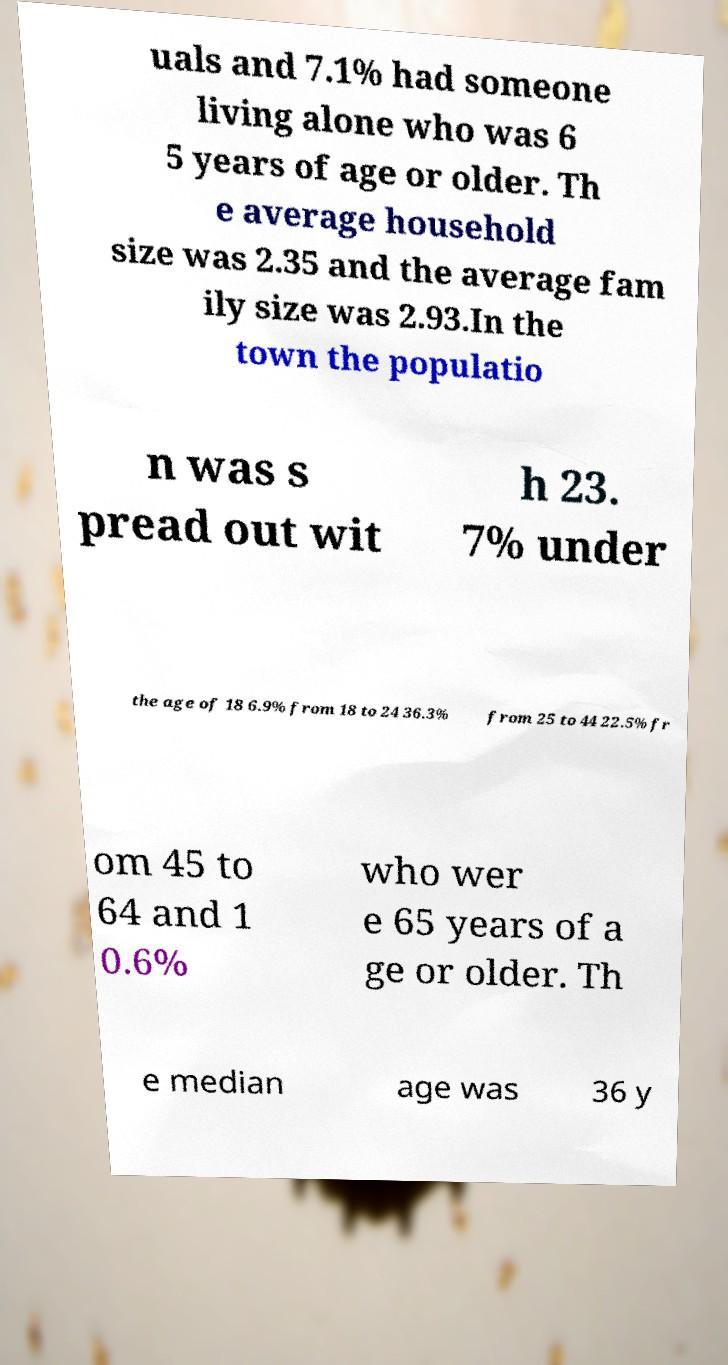There's text embedded in this image that I need extracted. Can you transcribe it verbatim? uals and 7.1% had someone living alone who was 6 5 years of age or older. Th e average household size was 2.35 and the average fam ily size was 2.93.In the town the populatio n was s pread out wit h 23. 7% under the age of 18 6.9% from 18 to 24 36.3% from 25 to 44 22.5% fr om 45 to 64 and 1 0.6% who wer e 65 years of a ge or older. Th e median age was 36 y 